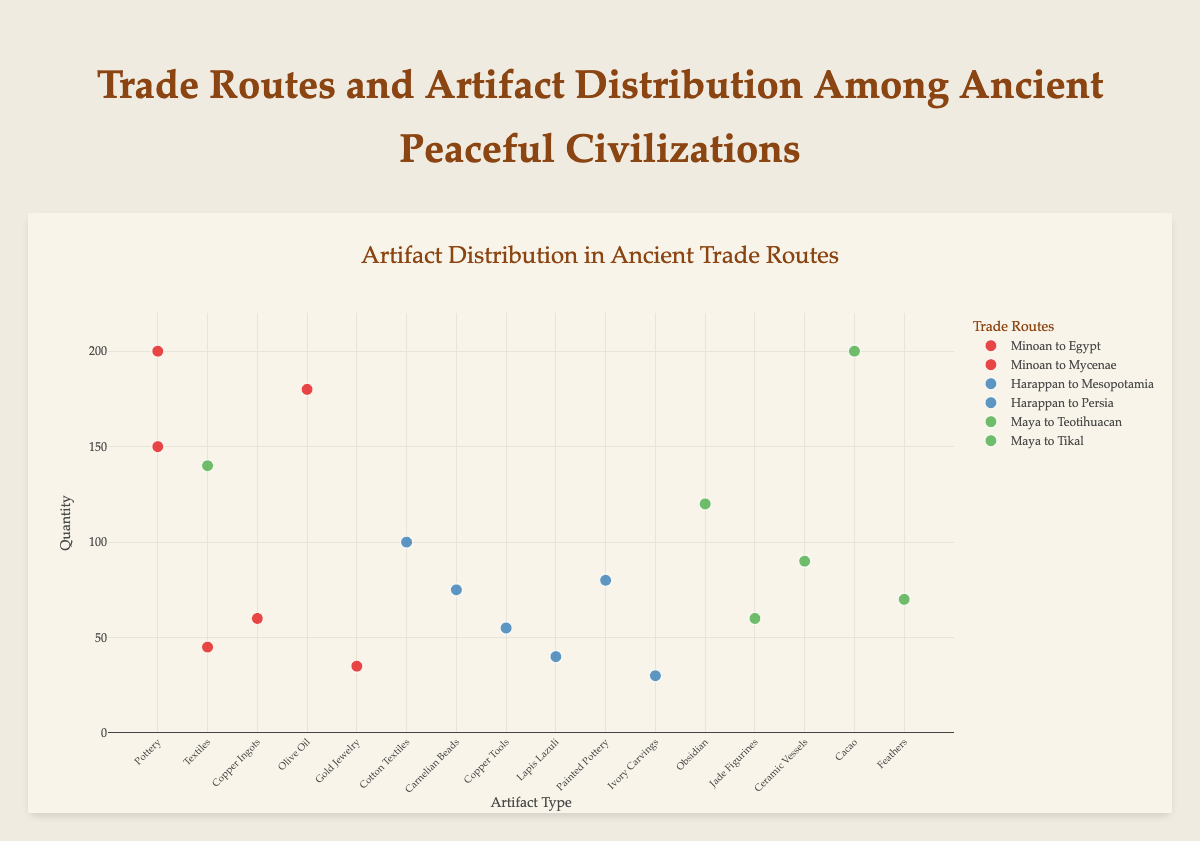What is the title of the plot? The title is typically found at the top of the plot and is meant to describe what the plot represents. In this case, it specifies that the data is about trade routes and artifact distribution among ancient peaceful civilizations.
Answer: Trade Routes and Artifact Distribution Among Ancient Peaceful Civilizations What artifact has the highest quantity in the "Minoan to Mycenae" trade route? Look for the data points associated with the "Minoan to Mycenae" trade route and compare their y-values. The highest y-value corresponds to the artifact with the highest quantity.
Answer: Olive Oil Which civilization has the most trade routes represented in the plot? Count the number of distinct trade routes for each civilization. Minoan has 2 routes, Harappan has 2 routes, and Maya has 2 routes. Since they are all equal, any of them could be considered the answer.
Answer: Minoan, Harappan, Maya How many data points are associated with the "Harappan to Persia" trade route? Identify the markers (data points) that belong to the "Harappan to Persia" trade route and count them. Each artifact corresponds to one data point.
Answer: 3 Which artifact is traded the least often among all trade routes? Compare the quantity values (y-values) of all artifacts across all trade routes.
Answer: Ivory Carvings What is the difference in quantity between "Cacao" from the Maya to Tikal route and "Copper Ingots" from the Minoan to Egypt route? Find the quantities for "Cacao" (200) and "Copper Ingots" (60), and compute the difference between these values.
Answer: 140 Which trade route has the least copper-related artifacts? Locate the data points for each trade route and look specifically at the artifacts related to copper, then compare the quantities.
Answer: Harappan to Persia Among the Maya civilization's trade routes, which route has a higher total quantity of artifacts? Sum the quantity values for the artifacts in the Maya to Teotihuacan route (120 + 60 + 90) and compare it with the sum for the Maya to Tikal route (200 + 70 + 140). The route with the higher total is the answer.
Answer: Maya to Tikal How many distinct artifact types are there in the plot? Identify all unique artifact types (x-values) presented in the plot and count them.
Answer: 12 What is the average quantity of artifacts traded by the Harappan civilization to Mesopotamia? Sum the quantities of artifacts (100 + 75 + 55 = 230) and divide by the number of artifacts (3) to find the average.
Answer: 76.67 